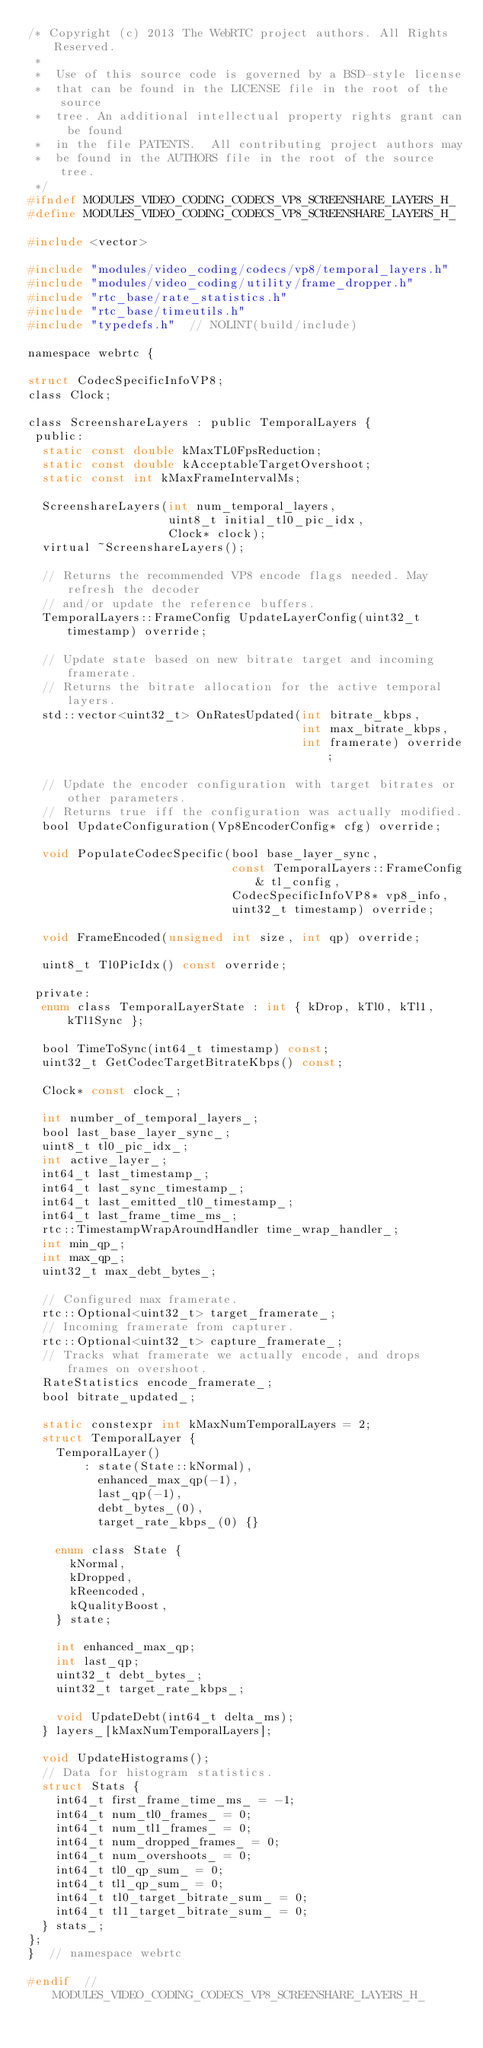<code> <loc_0><loc_0><loc_500><loc_500><_C_>/* Copyright (c) 2013 The WebRTC project authors. All Rights Reserved.
 *
 *  Use of this source code is governed by a BSD-style license
 *  that can be found in the LICENSE file in the root of the source
 *  tree. An additional intellectual property rights grant can be found
 *  in the file PATENTS.  All contributing project authors may
 *  be found in the AUTHORS file in the root of the source tree.
 */
#ifndef MODULES_VIDEO_CODING_CODECS_VP8_SCREENSHARE_LAYERS_H_
#define MODULES_VIDEO_CODING_CODECS_VP8_SCREENSHARE_LAYERS_H_

#include <vector>

#include "modules/video_coding/codecs/vp8/temporal_layers.h"
#include "modules/video_coding/utility/frame_dropper.h"
#include "rtc_base/rate_statistics.h"
#include "rtc_base/timeutils.h"
#include "typedefs.h"  // NOLINT(build/include)

namespace webrtc {

struct CodecSpecificInfoVP8;
class Clock;

class ScreenshareLayers : public TemporalLayers {
 public:
  static const double kMaxTL0FpsReduction;
  static const double kAcceptableTargetOvershoot;
  static const int kMaxFrameIntervalMs;

  ScreenshareLayers(int num_temporal_layers,
                    uint8_t initial_tl0_pic_idx,
                    Clock* clock);
  virtual ~ScreenshareLayers();

  // Returns the recommended VP8 encode flags needed. May refresh the decoder
  // and/or update the reference buffers.
  TemporalLayers::FrameConfig UpdateLayerConfig(uint32_t timestamp) override;

  // Update state based on new bitrate target and incoming framerate.
  // Returns the bitrate allocation for the active temporal layers.
  std::vector<uint32_t> OnRatesUpdated(int bitrate_kbps,
                                       int max_bitrate_kbps,
                                       int framerate) override;

  // Update the encoder configuration with target bitrates or other parameters.
  // Returns true iff the configuration was actually modified.
  bool UpdateConfiguration(Vp8EncoderConfig* cfg) override;

  void PopulateCodecSpecific(bool base_layer_sync,
                             const TemporalLayers::FrameConfig& tl_config,
                             CodecSpecificInfoVP8* vp8_info,
                             uint32_t timestamp) override;

  void FrameEncoded(unsigned int size, int qp) override;

  uint8_t Tl0PicIdx() const override;

 private:
  enum class TemporalLayerState : int { kDrop, kTl0, kTl1, kTl1Sync };

  bool TimeToSync(int64_t timestamp) const;
  uint32_t GetCodecTargetBitrateKbps() const;

  Clock* const clock_;

  int number_of_temporal_layers_;
  bool last_base_layer_sync_;
  uint8_t tl0_pic_idx_;
  int active_layer_;
  int64_t last_timestamp_;
  int64_t last_sync_timestamp_;
  int64_t last_emitted_tl0_timestamp_;
  int64_t last_frame_time_ms_;
  rtc::TimestampWrapAroundHandler time_wrap_handler_;
  int min_qp_;
  int max_qp_;
  uint32_t max_debt_bytes_;

  // Configured max framerate.
  rtc::Optional<uint32_t> target_framerate_;
  // Incoming framerate from capturer.
  rtc::Optional<uint32_t> capture_framerate_;
  // Tracks what framerate we actually encode, and drops frames on overshoot.
  RateStatistics encode_framerate_;
  bool bitrate_updated_;

  static constexpr int kMaxNumTemporalLayers = 2;
  struct TemporalLayer {
    TemporalLayer()
        : state(State::kNormal),
          enhanced_max_qp(-1),
          last_qp(-1),
          debt_bytes_(0),
          target_rate_kbps_(0) {}

    enum class State {
      kNormal,
      kDropped,
      kReencoded,
      kQualityBoost,
    } state;

    int enhanced_max_qp;
    int last_qp;
    uint32_t debt_bytes_;
    uint32_t target_rate_kbps_;

    void UpdateDebt(int64_t delta_ms);
  } layers_[kMaxNumTemporalLayers];

  void UpdateHistograms();
  // Data for histogram statistics.
  struct Stats {
    int64_t first_frame_time_ms_ = -1;
    int64_t num_tl0_frames_ = 0;
    int64_t num_tl1_frames_ = 0;
    int64_t num_dropped_frames_ = 0;
    int64_t num_overshoots_ = 0;
    int64_t tl0_qp_sum_ = 0;
    int64_t tl1_qp_sum_ = 0;
    int64_t tl0_target_bitrate_sum_ = 0;
    int64_t tl1_target_bitrate_sum_ = 0;
  } stats_;
};
}  // namespace webrtc

#endif  // MODULES_VIDEO_CODING_CODECS_VP8_SCREENSHARE_LAYERS_H_
</code> 